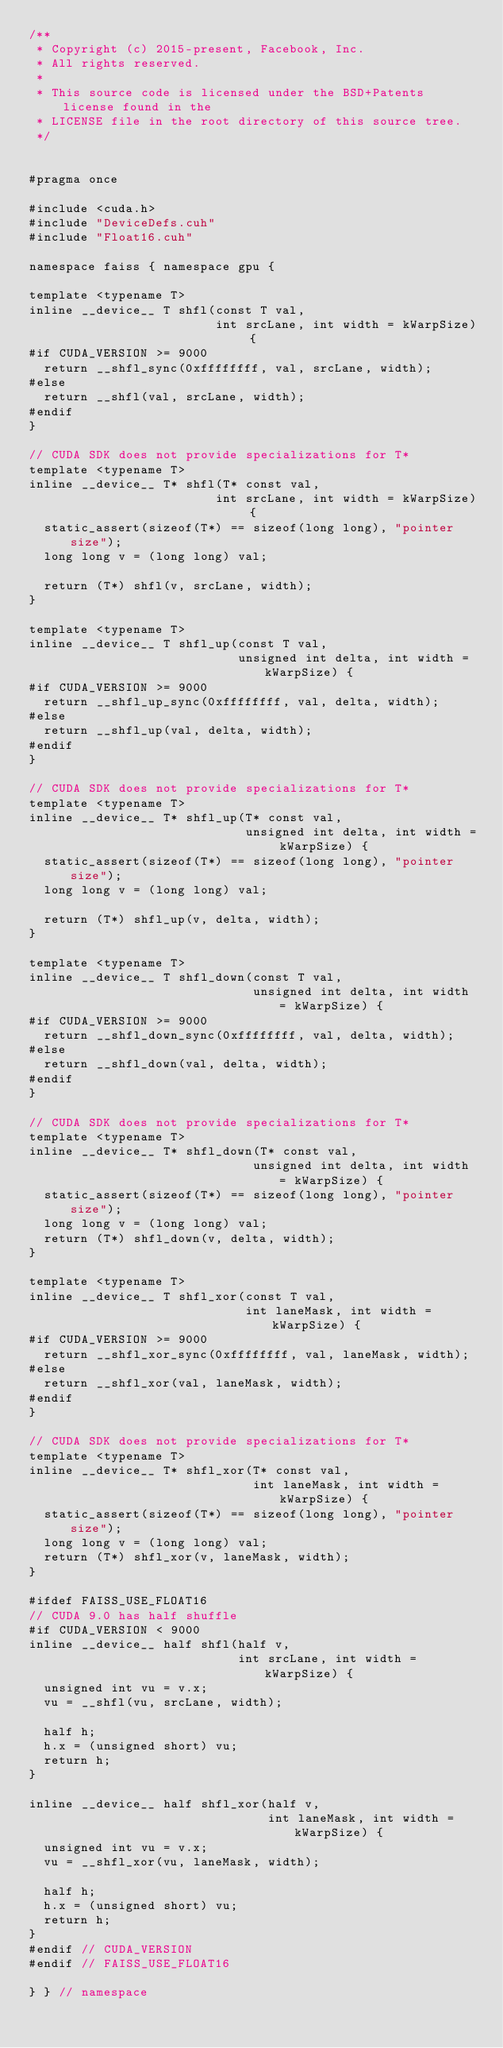<code> <loc_0><loc_0><loc_500><loc_500><_Cuda_>/**
 * Copyright (c) 2015-present, Facebook, Inc.
 * All rights reserved.
 *
 * This source code is licensed under the BSD+Patents license found in the
 * LICENSE file in the root directory of this source tree.
 */


#pragma once

#include <cuda.h>
#include "DeviceDefs.cuh"
#include "Float16.cuh"

namespace faiss { namespace gpu {

template <typename T>
inline __device__ T shfl(const T val,
                         int srcLane, int width = kWarpSize) {
#if CUDA_VERSION >= 9000
  return __shfl_sync(0xffffffff, val, srcLane, width);
#else
  return __shfl(val, srcLane, width);
#endif
}

// CUDA SDK does not provide specializations for T*
template <typename T>
inline __device__ T* shfl(T* const val,
                         int srcLane, int width = kWarpSize) {
  static_assert(sizeof(T*) == sizeof(long long), "pointer size");
  long long v = (long long) val;

  return (T*) shfl(v, srcLane, width);
}

template <typename T>
inline __device__ T shfl_up(const T val,
                            unsigned int delta, int width = kWarpSize) {
#if CUDA_VERSION >= 9000
  return __shfl_up_sync(0xffffffff, val, delta, width);
#else
  return __shfl_up(val, delta, width);
#endif
}

// CUDA SDK does not provide specializations for T*
template <typename T>
inline __device__ T* shfl_up(T* const val,
                             unsigned int delta, int width = kWarpSize) {
  static_assert(sizeof(T*) == sizeof(long long), "pointer size");
  long long v = (long long) val;

  return (T*) shfl_up(v, delta, width);
}

template <typename T>
inline __device__ T shfl_down(const T val,
                              unsigned int delta, int width = kWarpSize) {
#if CUDA_VERSION >= 9000
  return __shfl_down_sync(0xffffffff, val, delta, width);
#else
  return __shfl_down(val, delta, width);
#endif
}

// CUDA SDK does not provide specializations for T*
template <typename T>
inline __device__ T* shfl_down(T* const val,
                              unsigned int delta, int width = kWarpSize) {
  static_assert(sizeof(T*) == sizeof(long long), "pointer size");
  long long v = (long long) val;
  return (T*) shfl_down(v, delta, width);
}

template <typename T>
inline __device__ T shfl_xor(const T val,
                             int laneMask, int width = kWarpSize) {
#if CUDA_VERSION >= 9000
  return __shfl_xor_sync(0xffffffff, val, laneMask, width);
#else
  return __shfl_xor(val, laneMask, width);
#endif
}

// CUDA SDK does not provide specializations for T*
template <typename T>
inline __device__ T* shfl_xor(T* const val,
                              int laneMask, int width = kWarpSize) {
  static_assert(sizeof(T*) == sizeof(long long), "pointer size");
  long long v = (long long) val;
  return (T*) shfl_xor(v, laneMask, width);
}

#ifdef FAISS_USE_FLOAT16
// CUDA 9.0 has half shuffle
#if CUDA_VERSION < 9000
inline __device__ half shfl(half v,
                            int srcLane, int width = kWarpSize) {
  unsigned int vu = v.x;
  vu = __shfl(vu, srcLane, width);

  half h;
  h.x = (unsigned short) vu;
  return h;
}

inline __device__ half shfl_xor(half v,
                                int laneMask, int width = kWarpSize) {
  unsigned int vu = v.x;
  vu = __shfl_xor(vu, laneMask, width);

  half h;
  h.x = (unsigned short) vu;
  return h;
}
#endif // CUDA_VERSION
#endif // FAISS_USE_FLOAT16

} } // namespace
</code> 